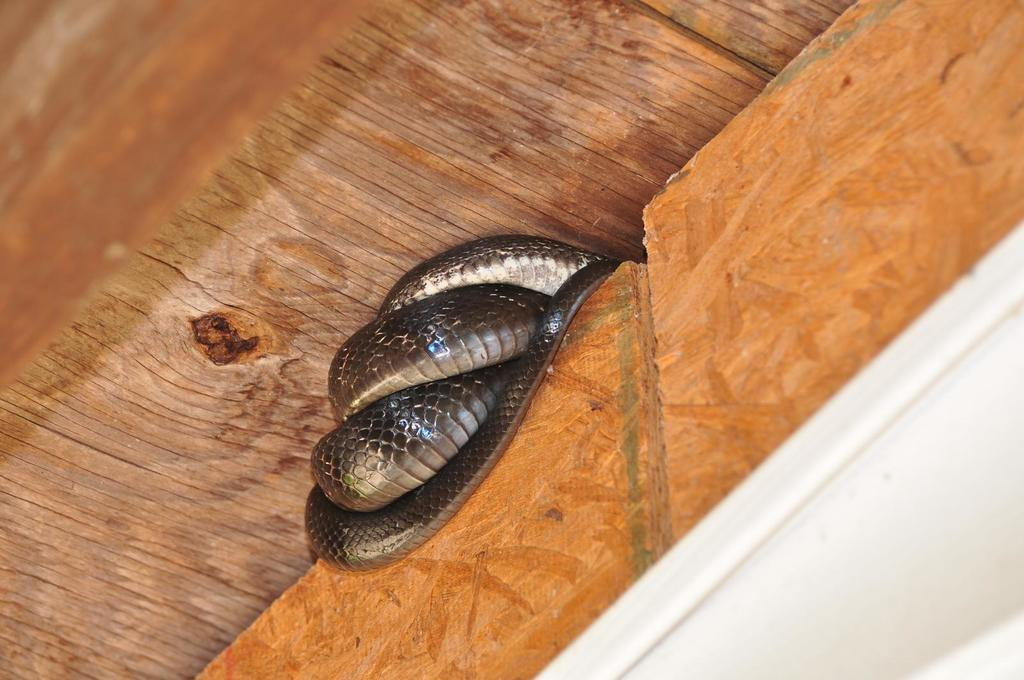What animal is on the wall in the image? There is a snake on the wall in the image. What type of flooring is visible at the bottom of the image? There is a wooden floor at the bottom of the image. What type of office furniture can be seen in the image? There is no office furniture present in the image; it features a snake on the wall and a wooden floor. How many trucks are visible in the image? There are no trucks visible in the image. 